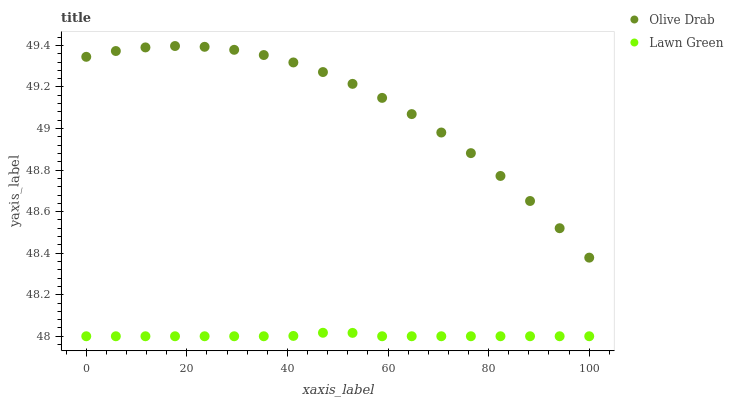Does Lawn Green have the minimum area under the curve?
Answer yes or no. Yes. Does Olive Drab have the maximum area under the curve?
Answer yes or no. Yes. Does Olive Drab have the minimum area under the curve?
Answer yes or no. No. Is Lawn Green the smoothest?
Answer yes or no. Yes. Is Olive Drab the roughest?
Answer yes or no. Yes. Is Olive Drab the smoothest?
Answer yes or no. No. Does Lawn Green have the lowest value?
Answer yes or no. Yes. Does Olive Drab have the lowest value?
Answer yes or no. No. Does Olive Drab have the highest value?
Answer yes or no. Yes. Is Lawn Green less than Olive Drab?
Answer yes or no. Yes. Is Olive Drab greater than Lawn Green?
Answer yes or no. Yes. Does Lawn Green intersect Olive Drab?
Answer yes or no. No. 